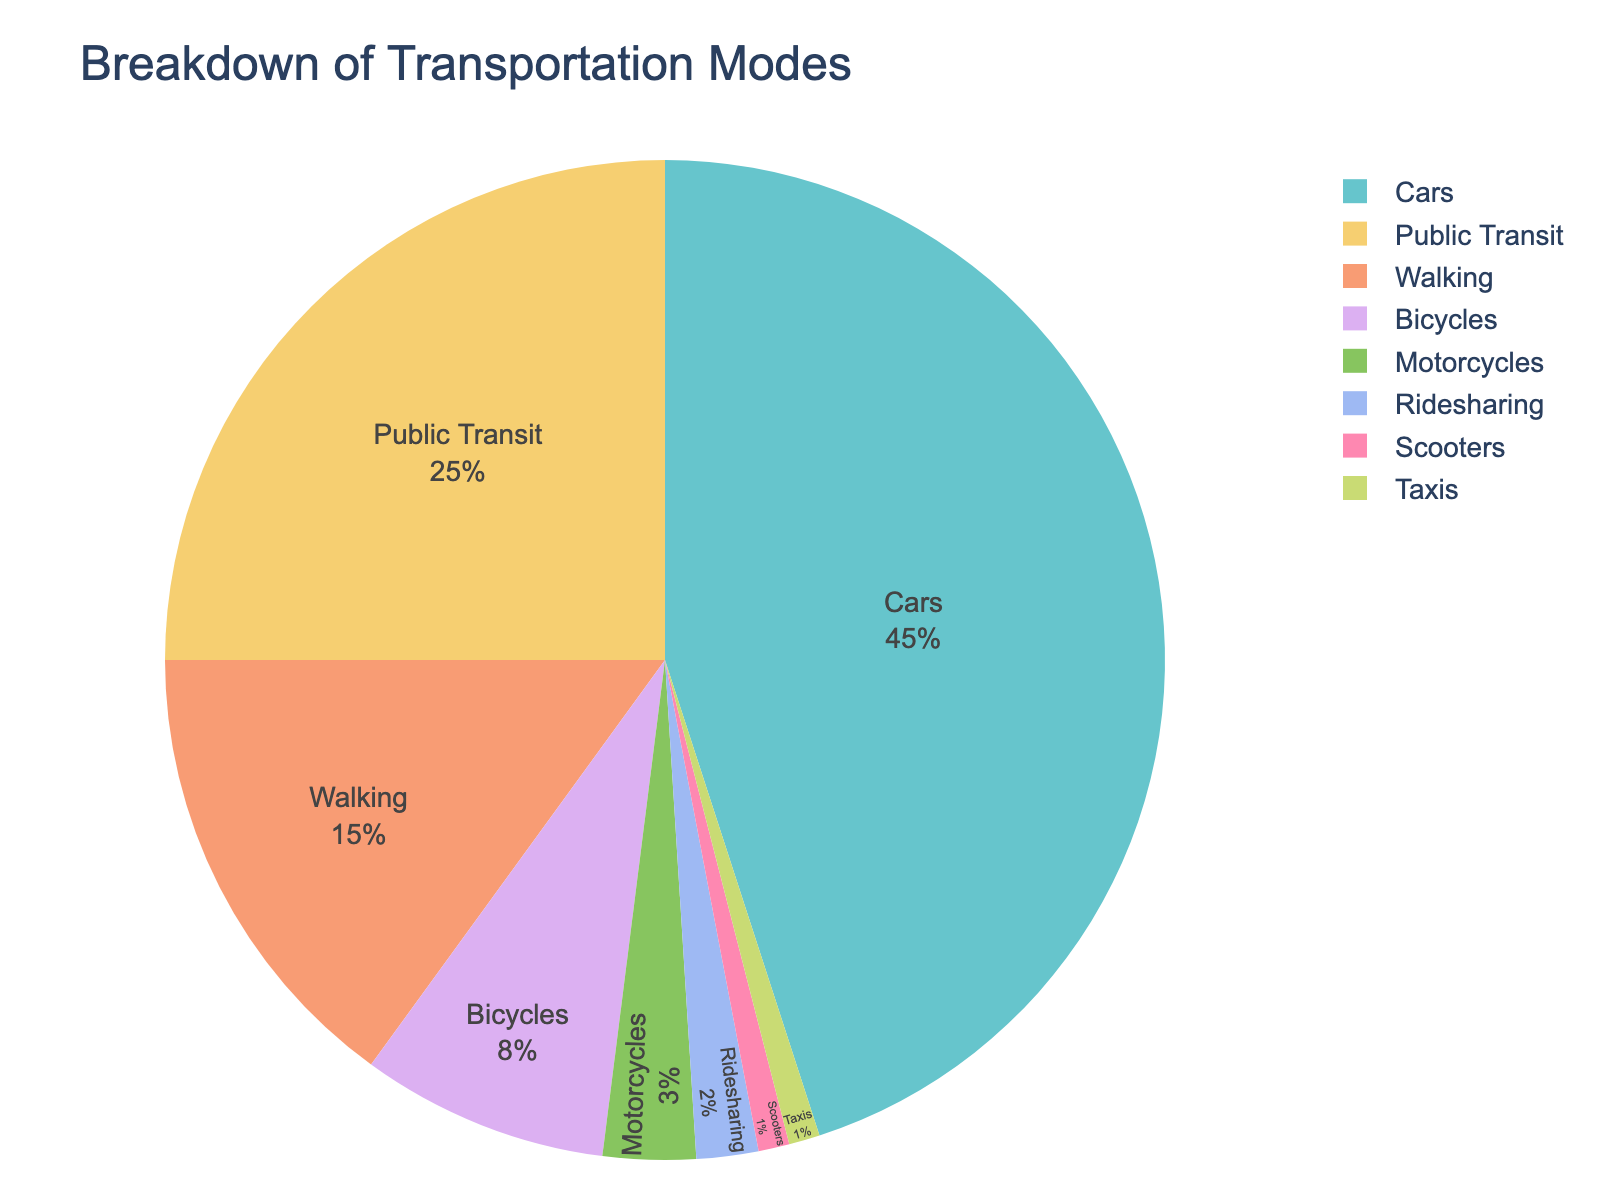What's the most popular transportation mode among city residents? To determine the most popular transportation mode, you need to look for the section with the largest percentage in the pie chart.
Answer: Cars What is the combined percentage of residents using Public Transit and Bicycles? Add the percentages of Public Transit and Bicycles together: 25% (Public Transit) + 8% (Bicycles) = 33%.
Answer: 33% Which transportation mode is less popular, Walking or Motorcycles? Compare the percentages of Walking and Motorcycles. Walking is 15%, and Motorcycles is 3%, so Motorcycles is less popular.
Answer: Motorcycles By what percentage do Cars exceed Public Transit usage? Subtract the percentage of Public Transit from the percentage of Cars: 45% (Cars) - 25% (Public Transit) = 20%.
Answer: 20% How much higher is the percentage of Cars compared to Ridesharing, Scooters, and Taxis combined? Add the percentages of Ridesharing, Scooters, and Taxis: 2% + 1% + 1% = 4%. Then subtract this total from the percentage of Cars: 45% - 4% = 41%.
Answer: 41% What transportation modes together constitute exactly half of the transportation usage? Sum the percentages iteratively to reach 50%. For example, Cars (45%) + Scooters (1%) + Taxis (1%) + Ridesharing (2%) + Motorcycles (3%) = 52% is too high, but Cars (45%) + Motorcycles (3%) + Ridesharing (2%) = 50%.
Answer: Cars, Motorcycles, Ridesharing Which segments of the pie chart have the smallest representation? Identify the sections with the smallest percentages; here, it's Scooters and Taxis, each with 1%.
Answer: Scooters, Taxis What is the difference in percentage between the least and the most popular transportation modes? Identify the most popular mode (Cars at 45%) and the least popular modes (Scooters and Taxis at 1%). Subtract the smallest value from the largest: 45% - 1% = 44%.
Answer: 44% 